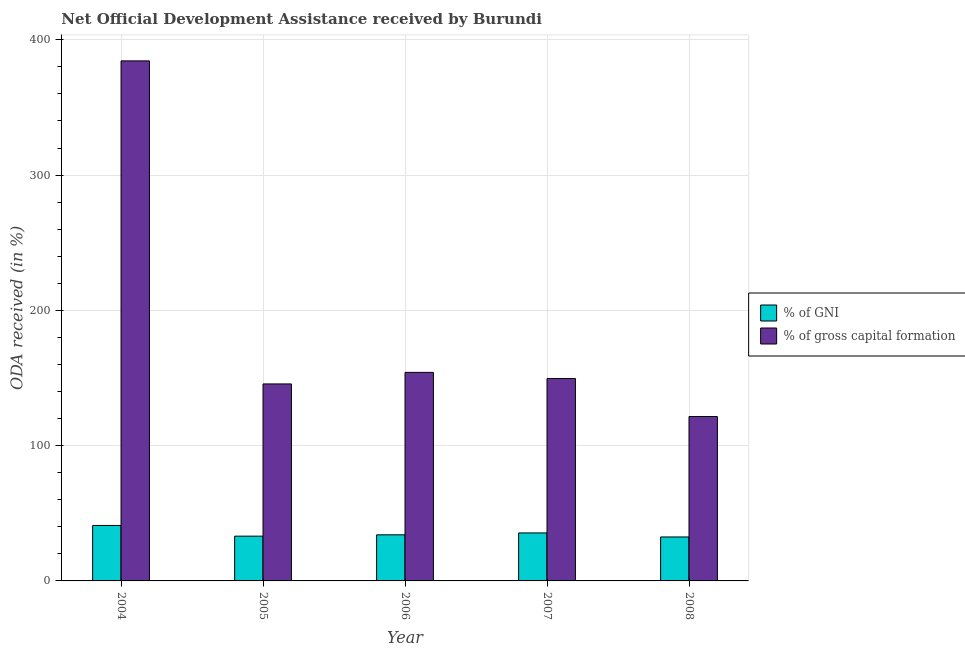How many groups of bars are there?
Your answer should be very brief. 5. Are the number of bars per tick equal to the number of legend labels?
Keep it short and to the point. Yes. Are the number of bars on each tick of the X-axis equal?
Your response must be concise. Yes. How many bars are there on the 3rd tick from the right?
Your response must be concise. 2. What is the label of the 2nd group of bars from the left?
Keep it short and to the point. 2005. What is the oda received as percentage of gross capital formation in 2007?
Give a very brief answer. 149.63. Across all years, what is the maximum oda received as percentage of gross capital formation?
Ensure brevity in your answer.  384.4. Across all years, what is the minimum oda received as percentage of gross capital formation?
Your answer should be compact. 121.53. In which year was the oda received as percentage of gni maximum?
Ensure brevity in your answer.  2004. In which year was the oda received as percentage of gni minimum?
Make the answer very short. 2008. What is the total oda received as percentage of gni in the graph?
Keep it short and to the point. 176.15. What is the difference between the oda received as percentage of gross capital formation in 2004 and that in 2005?
Give a very brief answer. 238.8. What is the difference between the oda received as percentage of gross capital formation in 2005 and the oda received as percentage of gni in 2004?
Keep it short and to the point. -238.8. What is the average oda received as percentage of gross capital formation per year?
Your answer should be very brief. 191.06. In how many years, is the oda received as percentage of gross capital formation greater than 140 %?
Offer a very short reply. 4. What is the ratio of the oda received as percentage of gross capital formation in 2004 to that in 2007?
Offer a very short reply. 2.57. Is the oda received as percentage of gni in 2006 less than that in 2008?
Offer a very short reply. No. What is the difference between the highest and the second highest oda received as percentage of gni?
Give a very brief answer. 5.52. What is the difference between the highest and the lowest oda received as percentage of gross capital formation?
Your answer should be compact. 262.87. Is the sum of the oda received as percentage of gni in 2004 and 2006 greater than the maximum oda received as percentage of gross capital formation across all years?
Provide a short and direct response. Yes. What does the 2nd bar from the left in 2007 represents?
Your answer should be very brief. % of gross capital formation. What does the 1st bar from the right in 2005 represents?
Make the answer very short. % of gross capital formation. What is the difference between two consecutive major ticks on the Y-axis?
Your response must be concise. 100. Does the graph contain grids?
Your answer should be very brief. Yes. How many legend labels are there?
Give a very brief answer. 2. What is the title of the graph?
Make the answer very short. Net Official Development Assistance received by Burundi. Does "Study and work" appear as one of the legend labels in the graph?
Offer a very short reply. No. What is the label or title of the Y-axis?
Offer a very short reply. ODA received (in %). What is the ODA received (in %) in % of GNI in 2004?
Provide a short and direct response. 41. What is the ODA received (in %) of % of gross capital formation in 2004?
Make the answer very short. 384.4. What is the ODA received (in %) in % of GNI in 2005?
Provide a succinct answer. 33.1. What is the ODA received (in %) of % of gross capital formation in 2005?
Offer a very short reply. 145.61. What is the ODA received (in %) of % of GNI in 2006?
Your answer should be very brief. 34.08. What is the ODA received (in %) in % of gross capital formation in 2006?
Make the answer very short. 154.15. What is the ODA received (in %) of % of GNI in 2007?
Your answer should be compact. 35.48. What is the ODA received (in %) in % of gross capital formation in 2007?
Ensure brevity in your answer.  149.63. What is the ODA received (in %) in % of GNI in 2008?
Keep it short and to the point. 32.49. What is the ODA received (in %) in % of gross capital formation in 2008?
Keep it short and to the point. 121.53. Across all years, what is the maximum ODA received (in %) in % of GNI?
Provide a short and direct response. 41. Across all years, what is the maximum ODA received (in %) in % of gross capital formation?
Ensure brevity in your answer.  384.4. Across all years, what is the minimum ODA received (in %) of % of GNI?
Make the answer very short. 32.49. Across all years, what is the minimum ODA received (in %) in % of gross capital formation?
Make the answer very short. 121.53. What is the total ODA received (in %) in % of GNI in the graph?
Provide a succinct answer. 176.15. What is the total ODA received (in %) in % of gross capital formation in the graph?
Provide a succinct answer. 955.31. What is the difference between the ODA received (in %) of % of GNI in 2004 and that in 2005?
Ensure brevity in your answer.  7.9. What is the difference between the ODA received (in %) of % of gross capital formation in 2004 and that in 2005?
Provide a short and direct response. 238.8. What is the difference between the ODA received (in %) of % of GNI in 2004 and that in 2006?
Provide a short and direct response. 6.92. What is the difference between the ODA received (in %) of % of gross capital formation in 2004 and that in 2006?
Your answer should be very brief. 230.26. What is the difference between the ODA received (in %) in % of GNI in 2004 and that in 2007?
Offer a terse response. 5.52. What is the difference between the ODA received (in %) in % of gross capital formation in 2004 and that in 2007?
Offer a very short reply. 234.77. What is the difference between the ODA received (in %) in % of GNI in 2004 and that in 2008?
Provide a short and direct response. 8.51. What is the difference between the ODA received (in %) in % of gross capital formation in 2004 and that in 2008?
Your response must be concise. 262.87. What is the difference between the ODA received (in %) of % of GNI in 2005 and that in 2006?
Make the answer very short. -0.98. What is the difference between the ODA received (in %) in % of gross capital formation in 2005 and that in 2006?
Provide a succinct answer. -8.54. What is the difference between the ODA received (in %) of % of GNI in 2005 and that in 2007?
Your answer should be very brief. -2.38. What is the difference between the ODA received (in %) in % of gross capital formation in 2005 and that in 2007?
Offer a terse response. -4.02. What is the difference between the ODA received (in %) in % of GNI in 2005 and that in 2008?
Give a very brief answer. 0.61. What is the difference between the ODA received (in %) in % of gross capital formation in 2005 and that in 2008?
Provide a succinct answer. 24.08. What is the difference between the ODA received (in %) of % of GNI in 2006 and that in 2007?
Give a very brief answer. -1.4. What is the difference between the ODA received (in %) in % of gross capital formation in 2006 and that in 2007?
Give a very brief answer. 4.52. What is the difference between the ODA received (in %) in % of GNI in 2006 and that in 2008?
Provide a succinct answer. 1.59. What is the difference between the ODA received (in %) of % of gross capital formation in 2006 and that in 2008?
Make the answer very short. 32.62. What is the difference between the ODA received (in %) of % of GNI in 2007 and that in 2008?
Your answer should be compact. 2.99. What is the difference between the ODA received (in %) of % of gross capital formation in 2007 and that in 2008?
Offer a terse response. 28.1. What is the difference between the ODA received (in %) in % of GNI in 2004 and the ODA received (in %) in % of gross capital formation in 2005?
Offer a very short reply. -104.61. What is the difference between the ODA received (in %) of % of GNI in 2004 and the ODA received (in %) of % of gross capital formation in 2006?
Offer a terse response. -113.15. What is the difference between the ODA received (in %) in % of GNI in 2004 and the ODA received (in %) in % of gross capital formation in 2007?
Give a very brief answer. -108.63. What is the difference between the ODA received (in %) of % of GNI in 2004 and the ODA received (in %) of % of gross capital formation in 2008?
Your answer should be very brief. -80.53. What is the difference between the ODA received (in %) in % of GNI in 2005 and the ODA received (in %) in % of gross capital formation in 2006?
Provide a short and direct response. -121.05. What is the difference between the ODA received (in %) of % of GNI in 2005 and the ODA received (in %) of % of gross capital formation in 2007?
Offer a very short reply. -116.53. What is the difference between the ODA received (in %) of % of GNI in 2005 and the ODA received (in %) of % of gross capital formation in 2008?
Your response must be concise. -88.43. What is the difference between the ODA received (in %) of % of GNI in 2006 and the ODA received (in %) of % of gross capital formation in 2007?
Make the answer very short. -115.55. What is the difference between the ODA received (in %) of % of GNI in 2006 and the ODA received (in %) of % of gross capital formation in 2008?
Offer a very short reply. -87.45. What is the difference between the ODA received (in %) in % of GNI in 2007 and the ODA received (in %) in % of gross capital formation in 2008?
Your answer should be very brief. -86.05. What is the average ODA received (in %) in % of GNI per year?
Give a very brief answer. 35.23. What is the average ODA received (in %) in % of gross capital formation per year?
Give a very brief answer. 191.06. In the year 2004, what is the difference between the ODA received (in %) of % of GNI and ODA received (in %) of % of gross capital formation?
Your response must be concise. -343.41. In the year 2005, what is the difference between the ODA received (in %) of % of GNI and ODA received (in %) of % of gross capital formation?
Provide a short and direct response. -112.51. In the year 2006, what is the difference between the ODA received (in %) in % of GNI and ODA received (in %) in % of gross capital formation?
Give a very brief answer. -120.07. In the year 2007, what is the difference between the ODA received (in %) of % of GNI and ODA received (in %) of % of gross capital formation?
Provide a short and direct response. -114.15. In the year 2008, what is the difference between the ODA received (in %) in % of GNI and ODA received (in %) in % of gross capital formation?
Give a very brief answer. -89.04. What is the ratio of the ODA received (in %) of % of GNI in 2004 to that in 2005?
Ensure brevity in your answer.  1.24. What is the ratio of the ODA received (in %) of % of gross capital formation in 2004 to that in 2005?
Keep it short and to the point. 2.64. What is the ratio of the ODA received (in %) in % of GNI in 2004 to that in 2006?
Provide a succinct answer. 1.2. What is the ratio of the ODA received (in %) of % of gross capital formation in 2004 to that in 2006?
Your answer should be very brief. 2.49. What is the ratio of the ODA received (in %) of % of GNI in 2004 to that in 2007?
Provide a succinct answer. 1.16. What is the ratio of the ODA received (in %) of % of gross capital formation in 2004 to that in 2007?
Offer a terse response. 2.57. What is the ratio of the ODA received (in %) in % of GNI in 2004 to that in 2008?
Offer a terse response. 1.26. What is the ratio of the ODA received (in %) in % of gross capital formation in 2004 to that in 2008?
Your answer should be very brief. 3.16. What is the ratio of the ODA received (in %) of % of GNI in 2005 to that in 2006?
Ensure brevity in your answer.  0.97. What is the ratio of the ODA received (in %) in % of gross capital formation in 2005 to that in 2006?
Your response must be concise. 0.94. What is the ratio of the ODA received (in %) of % of GNI in 2005 to that in 2007?
Your answer should be compact. 0.93. What is the ratio of the ODA received (in %) of % of gross capital formation in 2005 to that in 2007?
Make the answer very short. 0.97. What is the ratio of the ODA received (in %) in % of GNI in 2005 to that in 2008?
Provide a short and direct response. 1.02. What is the ratio of the ODA received (in %) in % of gross capital formation in 2005 to that in 2008?
Your response must be concise. 1.2. What is the ratio of the ODA received (in %) in % of GNI in 2006 to that in 2007?
Offer a very short reply. 0.96. What is the ratio of the ODA received (in %) in % of gross capital formation in 2006 to that in 2007?
Provide a short and direct response. 1.03. What is the ratio of the ODA received (in %) of % of GNI in 2006 to that in 2008?
Offer a very short reply. 1.05. What is the ratio of the ODA received (in %) of % of gross capital formation in 2006 to that in 2008?
Provide a succinct answer. 1.27. What is the ratio of the ODA received (in %) in % of GNI in 2007 to that in 2008?
Your response must be concise. 1.09. What is the ratio of the ODA received (in %) in % of gross capital formation in 2007 to that in 2008?
Provide a succinct answer. 1.23. What is the difference between the highest and the second highest ODA received (in %) in % of GNI?
Offer a very short reply. 5.52. What is the difference between the highest and the second highest ODA received (in %) in % of gross capital formation?
Provide a succinct answer. 230.26. What is the difference between the highest and the lowest ODA received (in %) in % of GNI?
Offer a very short reply. 8.51. What is the difference between the highest and the lowest ODA received (in %) of % of gross capital formation?
Your answer should be very brief. 262.87. 